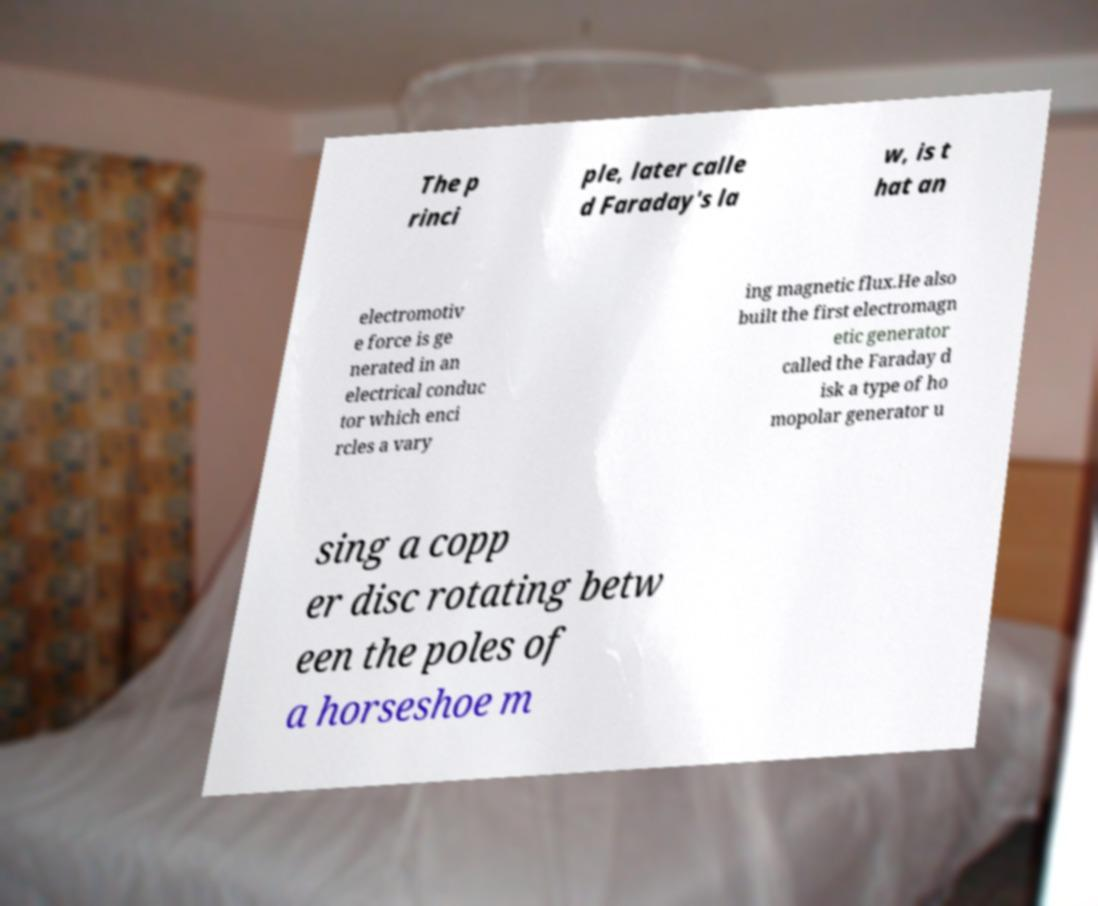Can you accurately transcribe the text from the provided image for me? The p rinci ple, later calle d Faraday's la w, is t hat an electromotiv e force is ge nerated in an electrical conduc tor which enci rcles a vary ing magnetic flux.He also built the first electromagn etic generator called the Faraday d isk a type of ho mopolar generator u sing a copp er disc rotating betw een the poles of a horseshoe m 